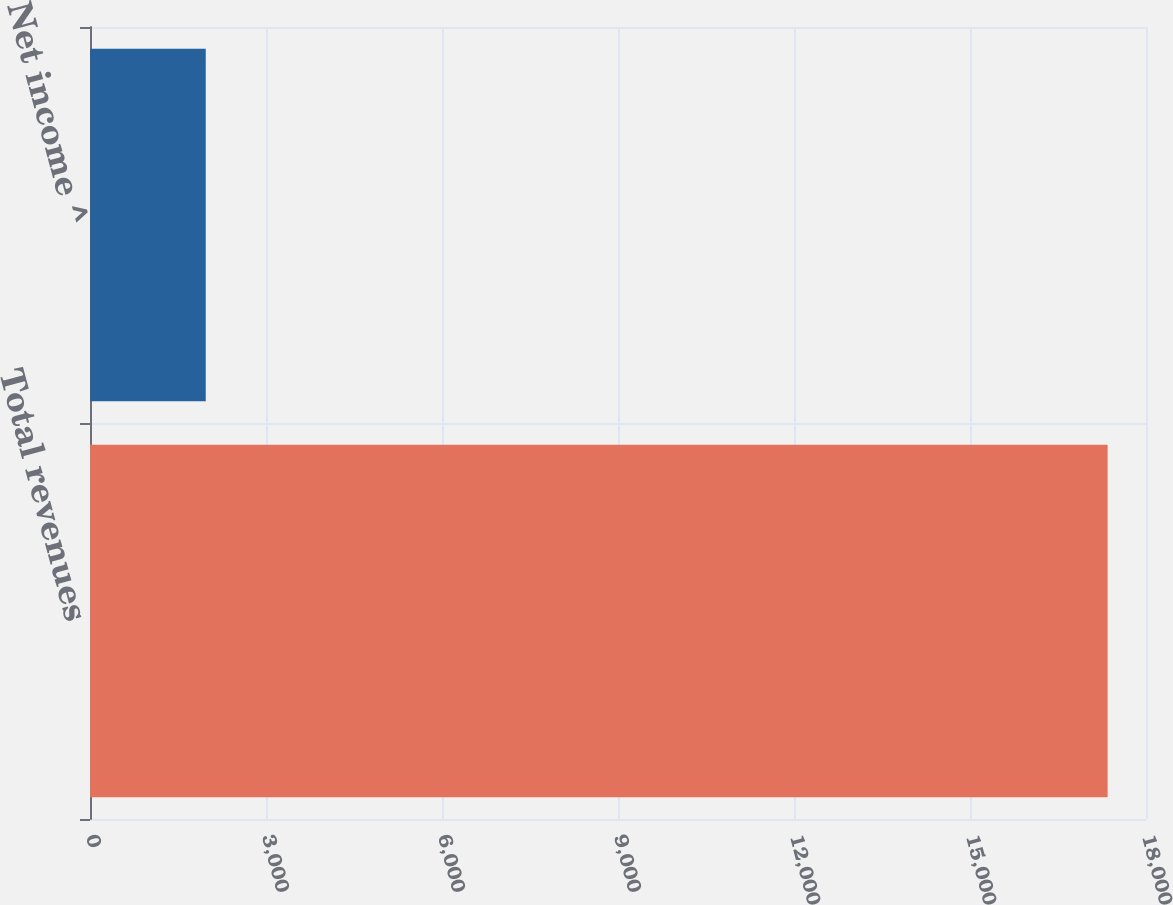Convert chart to OTSL. <chart><loc_0><loc_0><loc_500><loc_500><bar_chart><fcel>Total revenues<fcel>Net income ^<nl><fcel>17346<fcel>1973<nl></chart> 